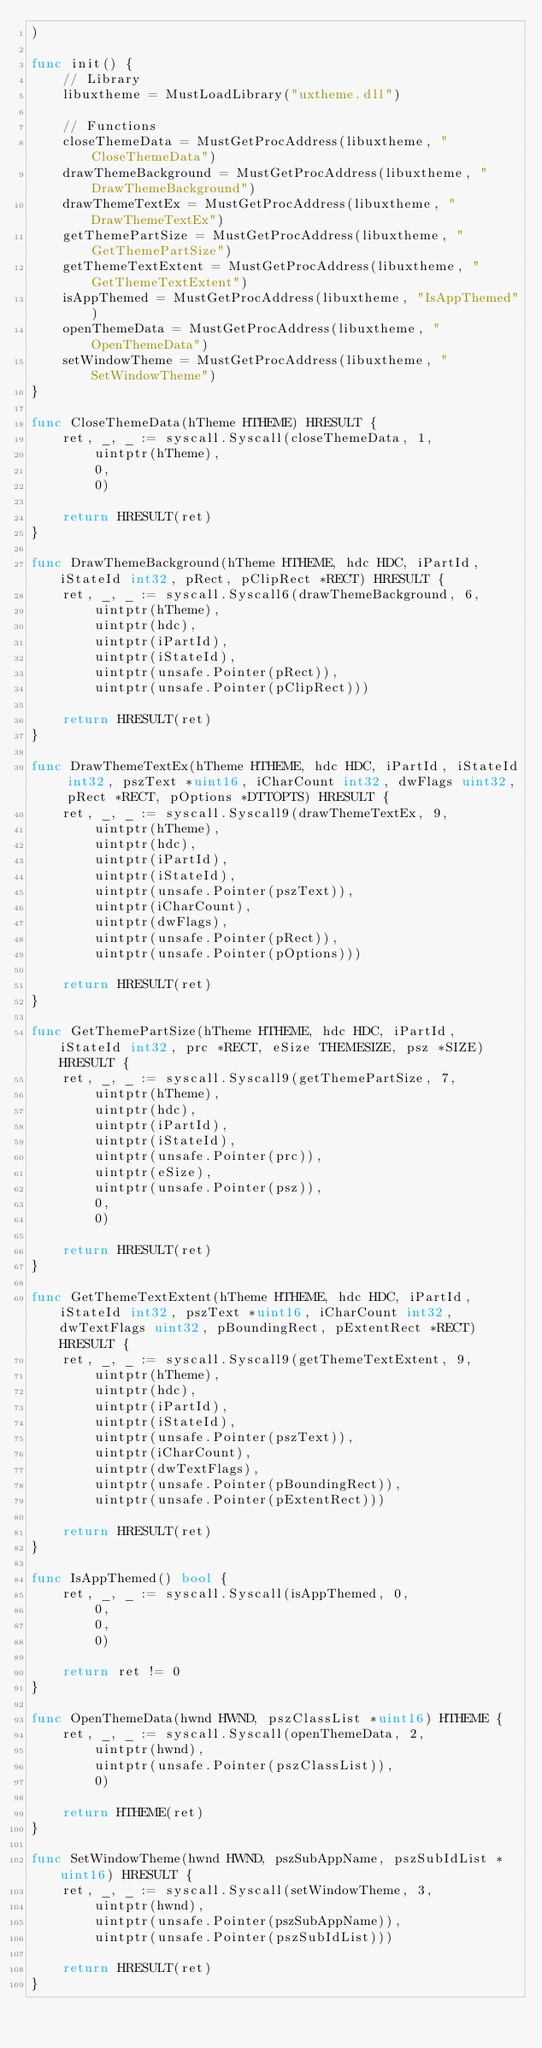<code> <loc_0><loc_0><loc_500><loc_500><_Go_>)

func init() {
	// Library
	libuxtheme = MustLoadLibrary("uxtheme.dll")

	// Functions
	closeThemeData = MustGetProcAddress(libuxtheme, "CloseThemeData")
	drawThemeBackground = MustGetProcAddress(libuxtheme, "DrawThemeBackground")
	drawThemeTextEx = MustGetProcAddress(libuxtheme, "DrawThemeTextEx")
	getThemePartSize = MustGetProcAddress(libuxtheme, "GetThemePartSize")
	getThemeTextExtent = MustGetProcAddress(libuxtheme, "GetThemeTextExtent")
	isAppThemed = MustGetProcAddress(libuxtheme, "IsAppThemed")
	openThemeData = MustGetProcAddress(libuxtheme, "OpenThemeData")
	setWindowTheme = MustGetProcAddress(libuxtheme, "SetWindowTheme")
}

func CloseThemeData(hTheme HTHEME) HRESULT {
	ret, _, _ := syscall.Syscall(closeThemeData, 1,
		uintptr(hTheme),
		0,
		0)

	return HRESULT(ret)
}

func DrawThemeBackground(hTheme HTHEME, hdc HDC, iPartId, iStateId int32, pRect, pClipRect *RECT) HRESULT {
	ret, _, _ := syscall.Syscall6(drawThemeBackground, 6,
		uintptr(hTheme),
		uintptr(hdc),
		uintptr(iPartId),
		uintptr(iStateId),
		uintptr(unsafe.Pointer(pRect)),
		uintptr(unsafe.Pointer(pClipRect)))

	return HRESULT(ret)
}

func DrawThemeTextEx(hTheme HTHEME, hdc HDC, iPartId, iStateId int32, pszText *uint16, iCharCount int32, dwFlags uint32, pRect *RECT, pOptions *DTTOPTS) HRESULT {
	ret, _, _ := syscall.Syscall9(drawThemeTextEx, 9,
		uintptr(hTheme),
		uintptr(hdc),
		uintptr(iPartId),
		uintptr(iStateId),
		uintptr(unsafe.Pointer(pszText)),
		uintptr(iCharCount),
		uintptr(dwFlags),
		uintptr(unsafe.Pointer(pRect)),
		uintptr(unsafe.Pointer(pOptions)))

	return HRESULT(ret)
}

func GetThemePartSize(hTheme HTHEME, hdc HDC, iPartId, iStateId int32, prc *RECT, eSize THEMESIZE, psz *SIZE) HRESULT {
	ret, _, _ := syscall.Syscall9(getThemePartSize, 7,
		uintptr(hTheme),
		uintptr(hdc),
		uintptr(iPartId),
		uintptr(iStateId),
		uintptr(unsafe.Pointer(prc)),
		uintptr(eSize),
		uintptr(unsafe.Pointer(psz)),
		0,
		0)

	return HRESULT(ret)
}

func GetThemeTextExtent(hTheme HTHEME, hdc HDC, iPartId, iStateId int32, pszText *uint16, iCharCount int32, dwTextFlags uint32, pBoundingRect, pExtentRect *RECT) HRESULT {
	ret, _, _ := syscall.Syscall9(getThemeTextExtent, 9,
		uintptr(hTheme),
		uintptr(hdc),
		uintptr(iPartId),
		uintptr(iStateId),
		uintptr(unsafe.Pointer(pszText)),
		uintptr(iCharCount),
		uintptr(dwTextFlags),
		uintptr(unsafe.Pointer(pBoundingRect)),
		uintptr(unsafe.Pointer(pExtentRect)))

	return HRESULT(ret)
}

func IsAppThemed() bool {
	ret, _, _ := syscall.Syscall(isAppThemed, 0,
		0,
		0,
		0)

	return ret != 0
}

func OpenThemeData(hwnd HWND, pszClassList *uint16) HTHEME {
	ret, _, _ := syscall.Syscall(openThemeData, 2,
		uintptr(hwnd),
		uintptr(unsafe.Pointer(pszClassList)),
		0)

	return HTHEME(ret)
}

func SetWindowTheme(hwnd HWND, pszSubAppName, pszSubIdList *uint16) HRESULT {
	ret, _, _ := syscall.Syscall(setWindowTheme, 3,
		uintptr(hwnd),
		uintptr(unsafe.Pointer(pszSubAppName)),
		uintptr(unsafe.Pointer(pszSubIdList)))

	return HRESULT(ret)
}
</code> 